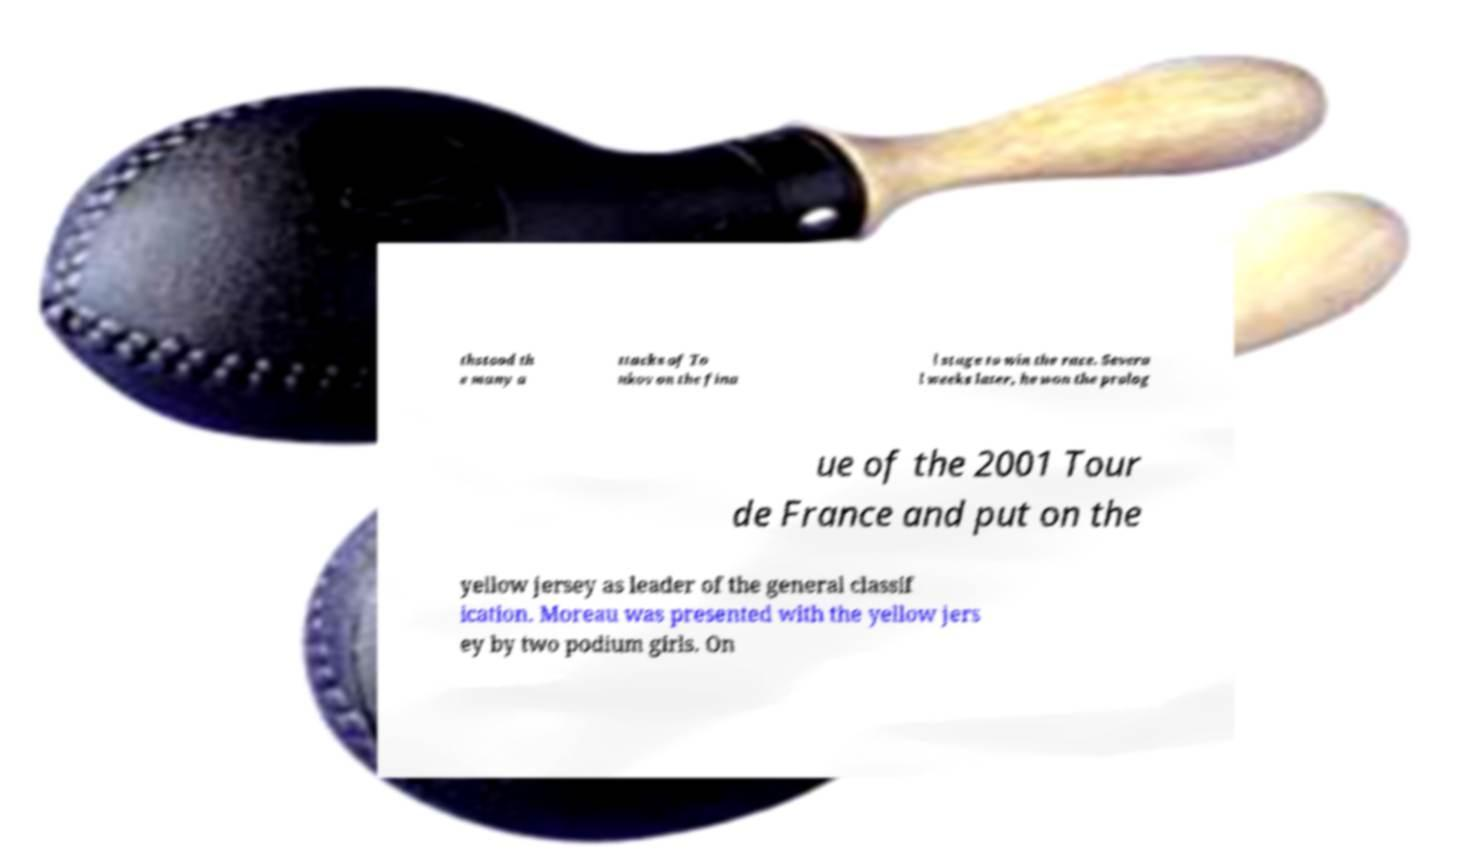Please read and relay the text visible in this image. What does it say? thstood th e many a ttacks of To nkov on the fina l stage to win the race. Severa l weeks later, he won the prolog ue of the 2001 Tour de France and put on the yellow jersey as leader of the general classif ication. Moreau was presented with the yellow jers ey by two podium girls. On 